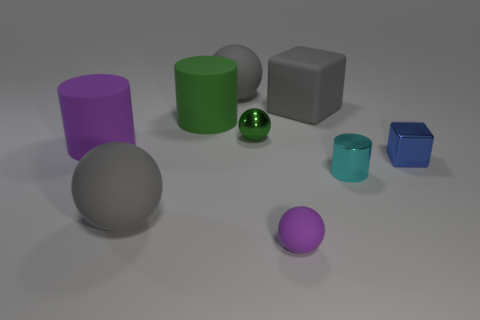What shape is the tiny thing that is to the left of the blue cube and to the right of the gray rubber block? cylinder 